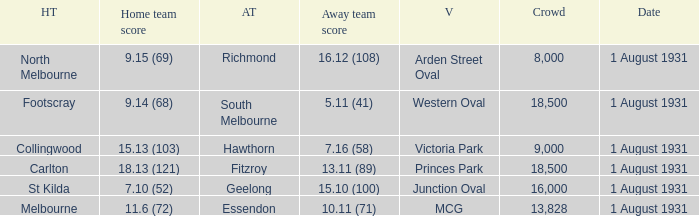What is the home teams score at Victoria Park? 15.13 (103). 